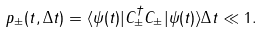Convert formula to latex. <formula><loc_0><loc_0><loc_500><loc_500>p _ { \pm } ( t , \Delta t ) = \langle \psi ( t ) | C _ { \pm } ^ { \dagger } C _ { \pm } | \psi ( t ) \rangle \Delta t \ll 1 .</formula> 